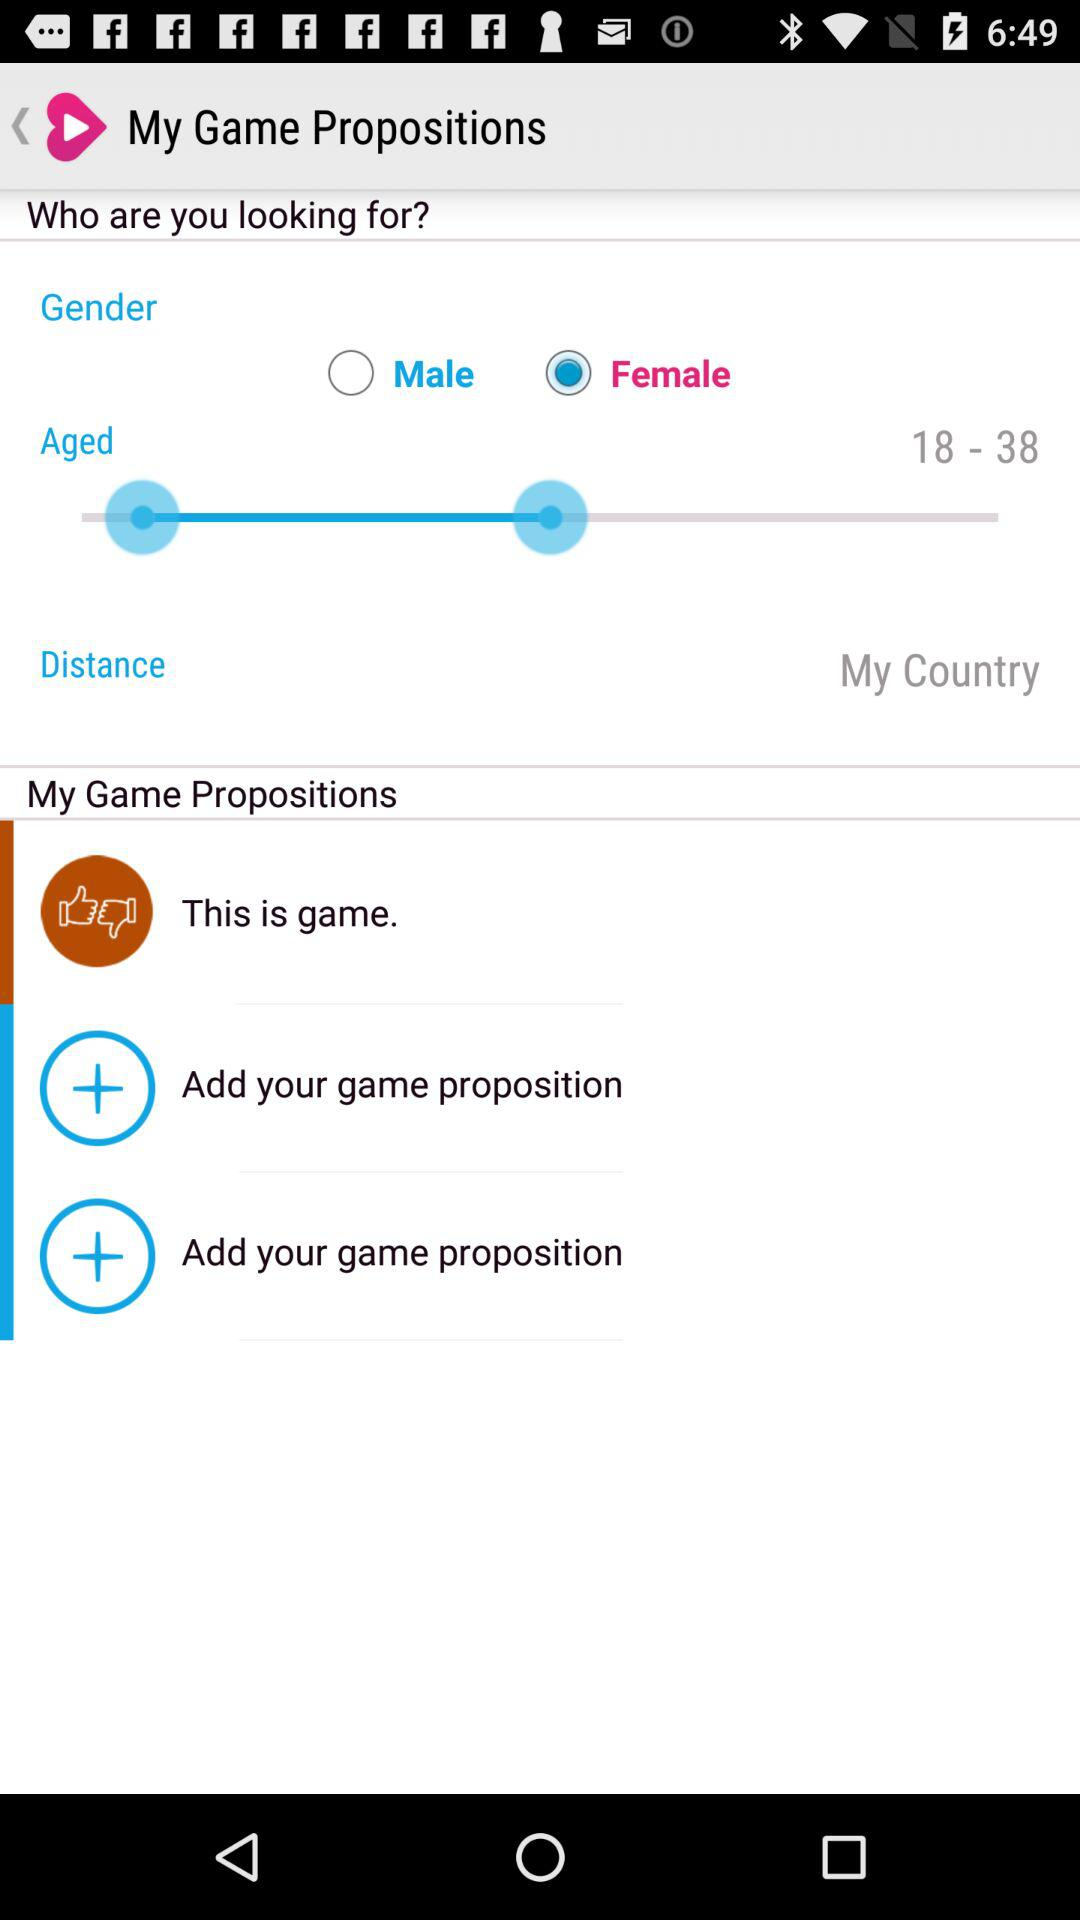What is the gender of the user? The gender of the user is female. 